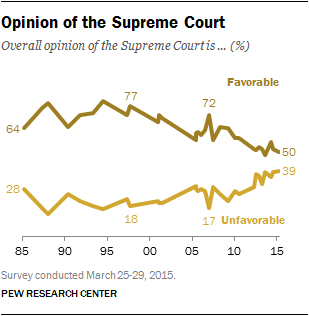List a handful of essential elements in this visual. The favorable and unfavorable rating of the Supreme Court in 1985 was 36 and 85, respectively. According to the Supreme Court's favorable rating in 2015, it was rated at 50. 